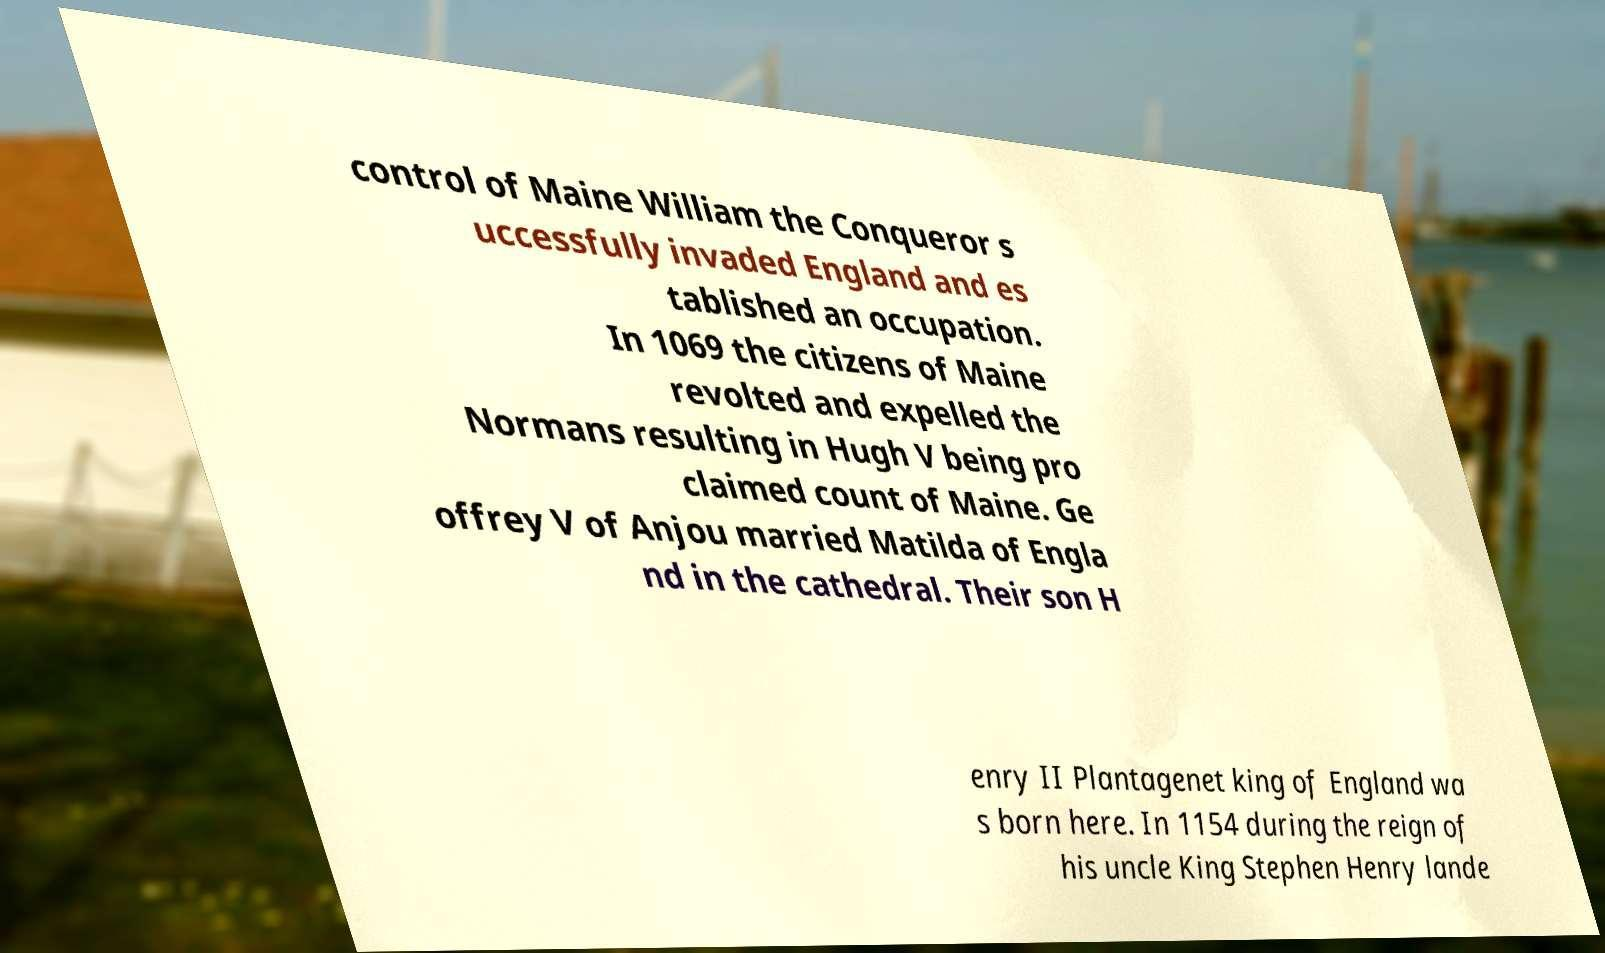What messages or text are displayed in this image? I need them in a readable, typed format. control of Maine William the Conqueror s uccessfully invaded England and es tablished an occupation. In 1069 the citizens of Maine revolted and expelled the Normans resulting in Hugh V being pro claimed count of Maine. Ge offrey V of Anjou married Matilda of Engla nd in the cathedral. Their son H enry II Plantagenet king of England wa s born here. In 1154 during the reign of his uncle King Stephen Henry lande 